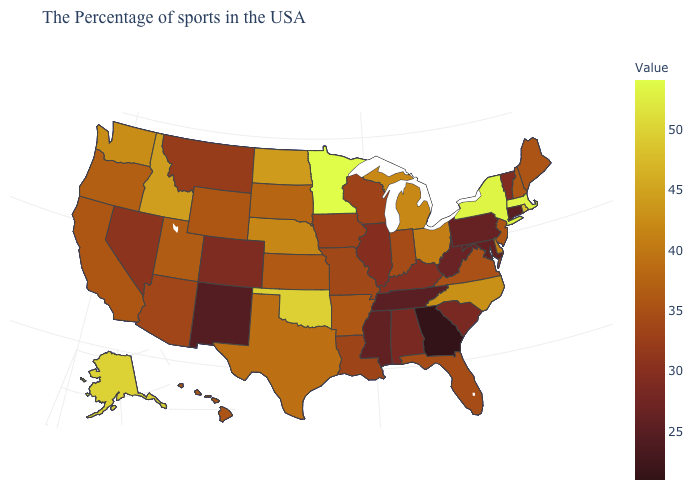Among the states that border Arizona , which have the highest value?
Give a very brief answer. Utah. Does Montana have a higher value than Connecticut?
Write a very short answer. Yes. Which states hav the highest value in the West?
Short answer required. Alaska. Which states have the lowest value in the USA?
Quick response, please. Georgia. Among the states that border Virginia , does Maryland have the highest value?
Keep it brief. No. Among the states that border Arizona , which have the lowest value?
Be succinct. New Mexico. Is the legend a continuous bar?
Answer briefly. Yes. 